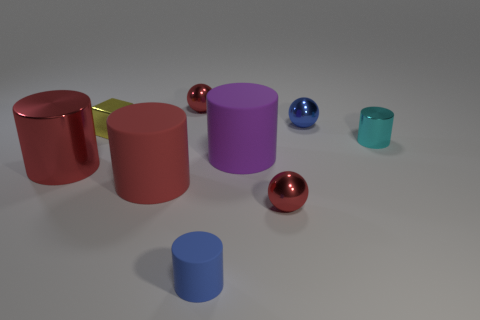Can you describe the lighting in the image? The lighting in the image is soft and diffuse, casting gentle shadows and highlighting the objects' textures and colors without creating harsh glares, contributing to the overall serene mood of the scene. 